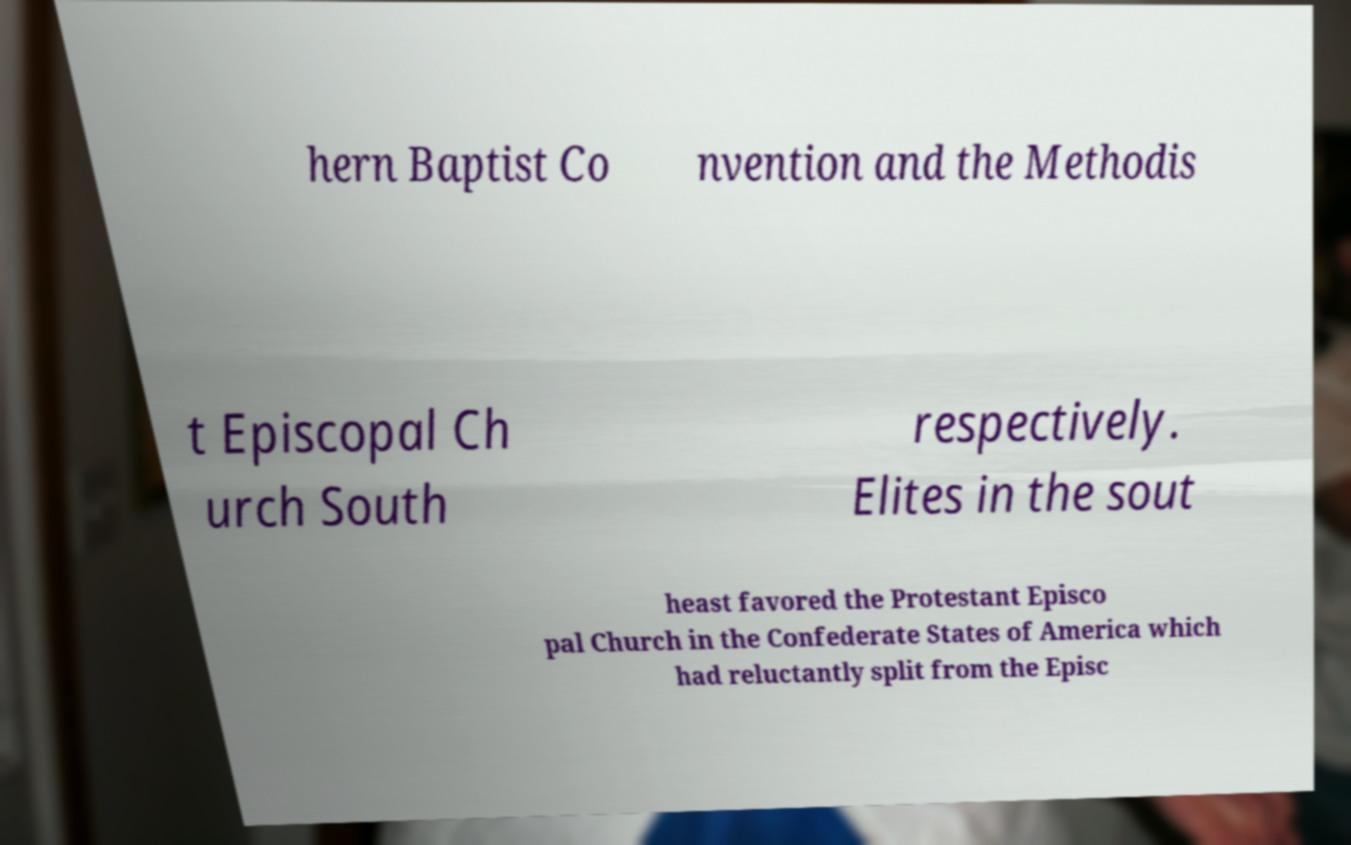Please identify and transcribe the text found in this image. hern Baptist Co nvention and the Methodis t Episcopal Ch urch South respectively. Elites in the sout heast favored the Protestant Episco pal Church in the Confederate States of America which had reluctantly split from the Episc 